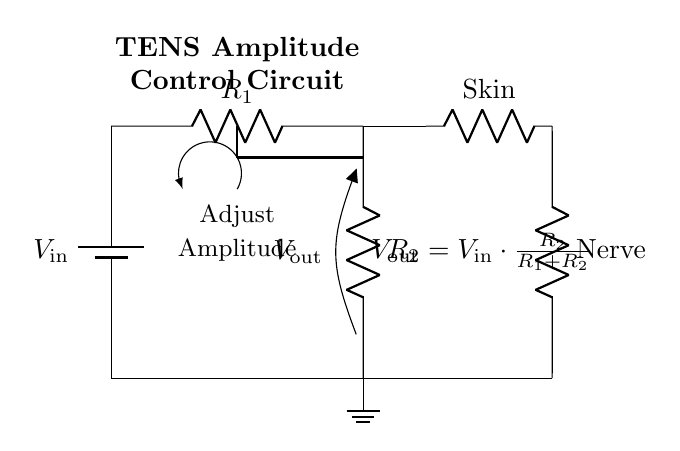What is \( V_{out} \) in terms of the resistors? From the circuit diagram, the output voltage, represented as \( V_{out} \), can be calculated using the formula provided, where \( V_{out} = V_{in} \times \frac{R_2}{R_1 + R_2} \). This means that the output voltage depends on the ratio of the resistors \( R_2 \) and \( R_1 \) relative to the total resistance.
Answer: \( V_{out} = V_{in} \cdot \frac{R_2}{R_1 + R_2} \) What components are used in this circuit? The circuit diagram illustrates two resistors labeled \( R_1 \) and \( R_2 \), a battery labeled \( V_{in} \), and connections to electrodes representing skin and nerve. These components are essential for constructing a voltage divider for amplitude adjustment.
Answer: Two resistors, a battery What does the potentionmeter do? In the circuit, the potentiometer allows for the adjustment of resistance effectively acting as \( R_2 \) in the voltage divider. By changing its position, you can alter \( V_{out} \), which controls the amplitude of electrical stimulation.
Answer: Adjusts resistance What is the function of \( V_{in} \)? \( V_{in} \) serves as the input voltage for the circuit, supplying the electrical energy needed for the TENS therapy application. It directly influences \( V_{out} \) based on the resistor values and the voltage divider formula.
Answer: Input voltage How does changing \( R_2 \) affect \( V_{out} \)? Increasing \( R_2 \) raises \( V_{out} \) according to the formula, thus increasing the amplitude of the stimulation. Conversely, decreasing \( R_2 \) will lower \( V_{out} \), reducing the stimulation amplitude. The ratio directly determines the output voltage.
Answer: Increases \( V_{out} \) 